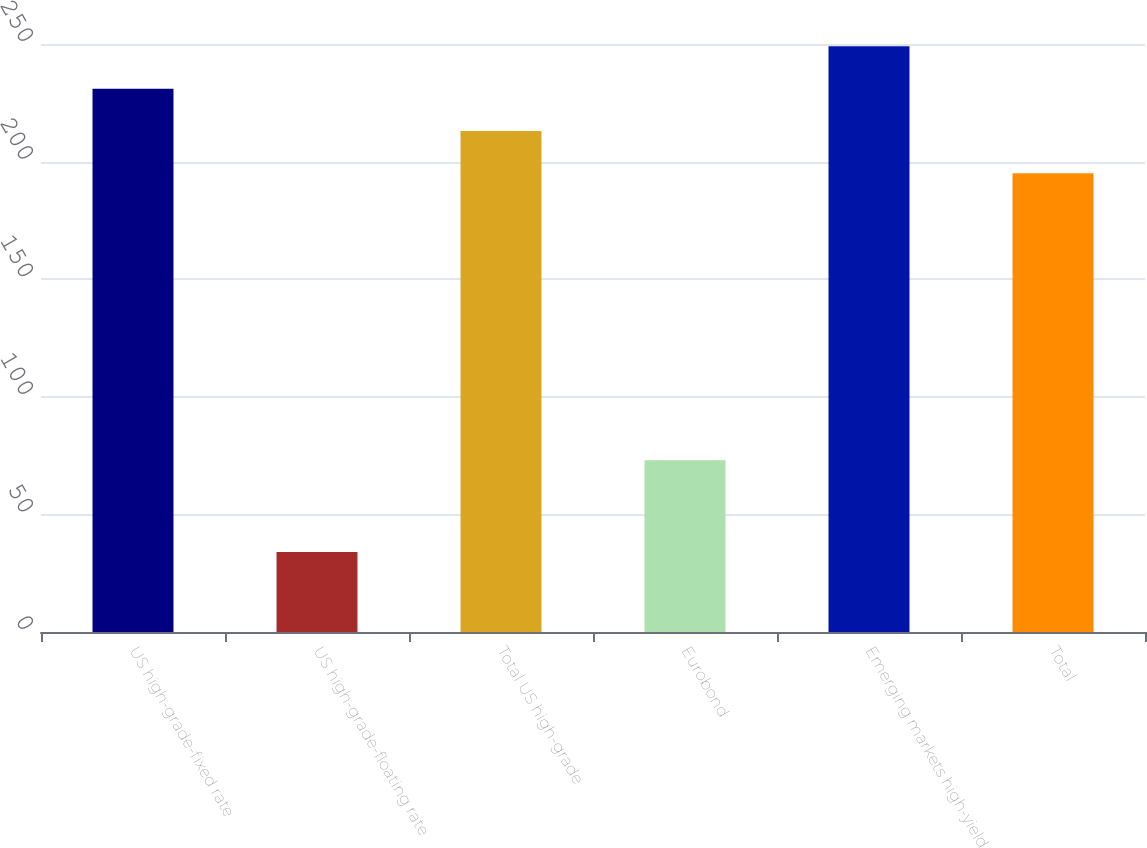Convert chart to OTSL. <chart><loc_0><loc_0><loc_500><loc_500><bar_chart><fcel>US high-grade-fixed rate<fcel>US high-grade-floating rate<fcel>Total US high-grade<fcel>Eurobond<fcel>Emerging markets high-yield<fcel>Total<nl><fcel>231<fcel>34<fcel>213<fcel>73<fcel>249<fcel>195<nl></chart> 